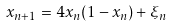Convert formula to latex. <formula><loc_0><loc_0><loc_500><loc_500>x _ { n + 1 } = 4 x _ { n } ( 1 - x _ { n } ) + \xi _ { n }</formula> 